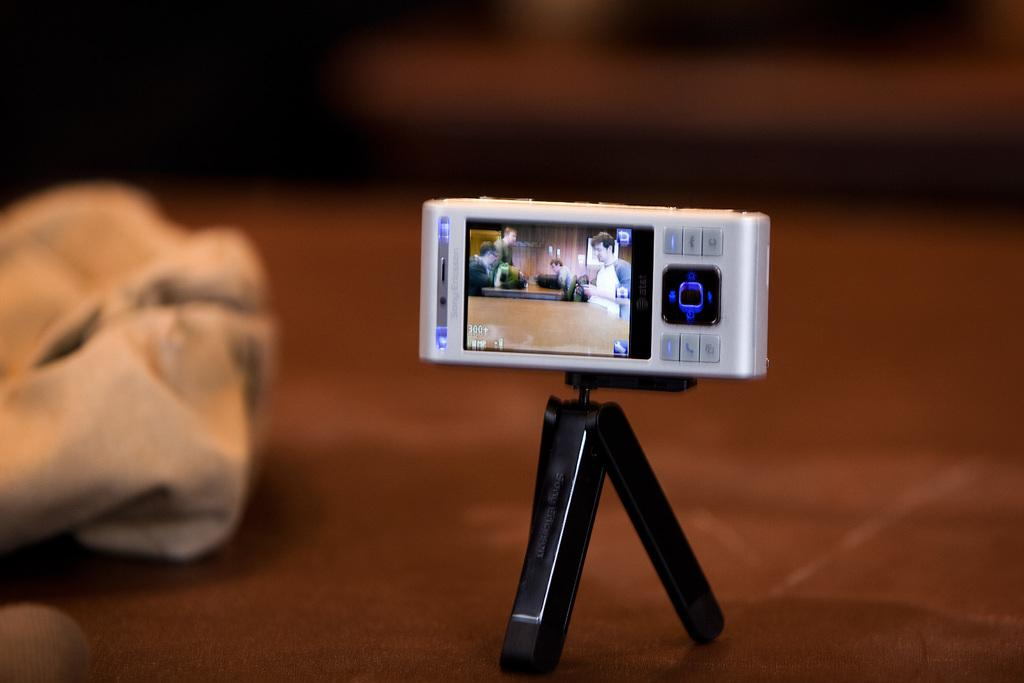What electronic device is visible in the image? There is a mobile phone in the image. What is the tall, three-legged object in the image? There is a tripod in the image. How would you describe the background of the image? The background of the image is blurred. What type of haircut is the hill getting in the image? There is no hill or haircut present in the image. What operation is being performed on the mobile phone in the image? There is no operation being performed on the mobile phone in the image; it is simply visible. 